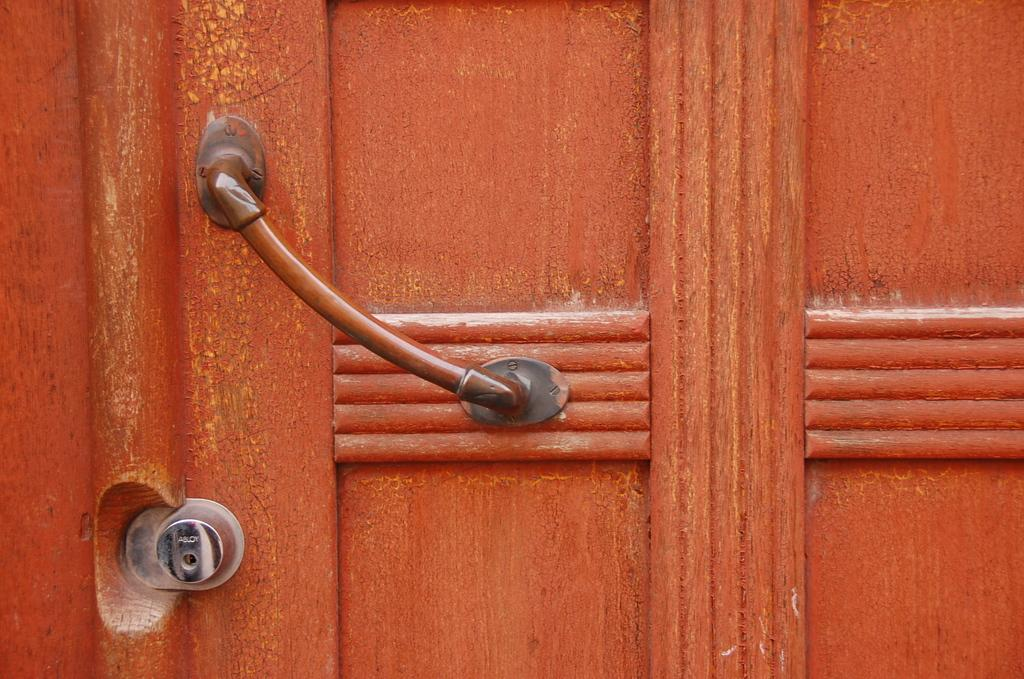What is the main object in the image? There is a door handle in the image. What type of material is the door made of? The door is made of wood. Are there any other objects attached to the wooden door? Yes, there are other objects attached to the wooden door. What type of quiver can be seen hanging from the door handle in the image? There is no quiver present in the image; it features a door handle and other objects attached to a wooden door. What type of wire is connected to the door handle in the image? There is no wire connected to the door handle in the image. 